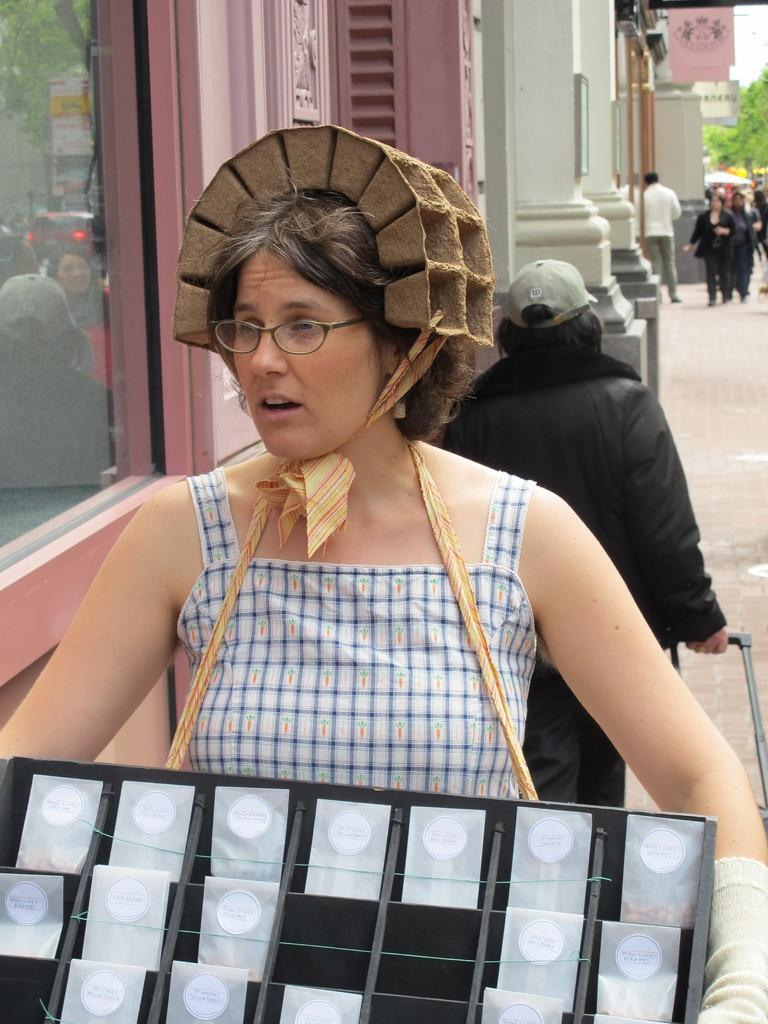What is the main subject of the image? There is a woman standing in the center of the image. Can you describe the woman's appearance? The woman is wearing spectacles. What can be seen in the background of the image? There are persons, buildings, trees, and the sky visible in the background of the image. What type of notebook is the woman holding in the image? There is no notebook present in the image. Is the woman using a hammer in the image? There is no hammer present in the image. 